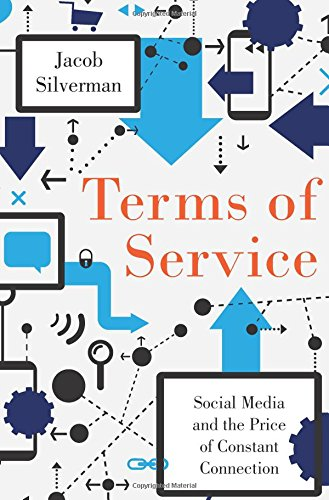What is the title of this book? The title of this insightful book is 'Terms of Service: Social Media and the Price of Constant Connection,' which delves into the complexities of our digital lives. 